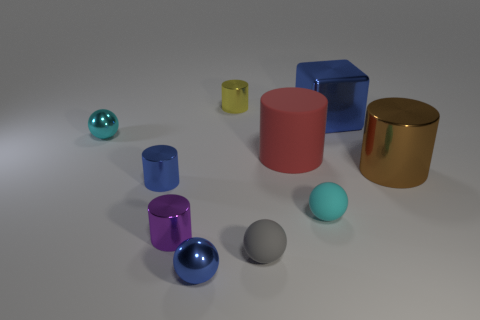If I were to sort these objects by their size, which one would be the smallest and which one the largest? The smallest object appears to be the tiny metal sphere, and the largest one is the big blue cube. 